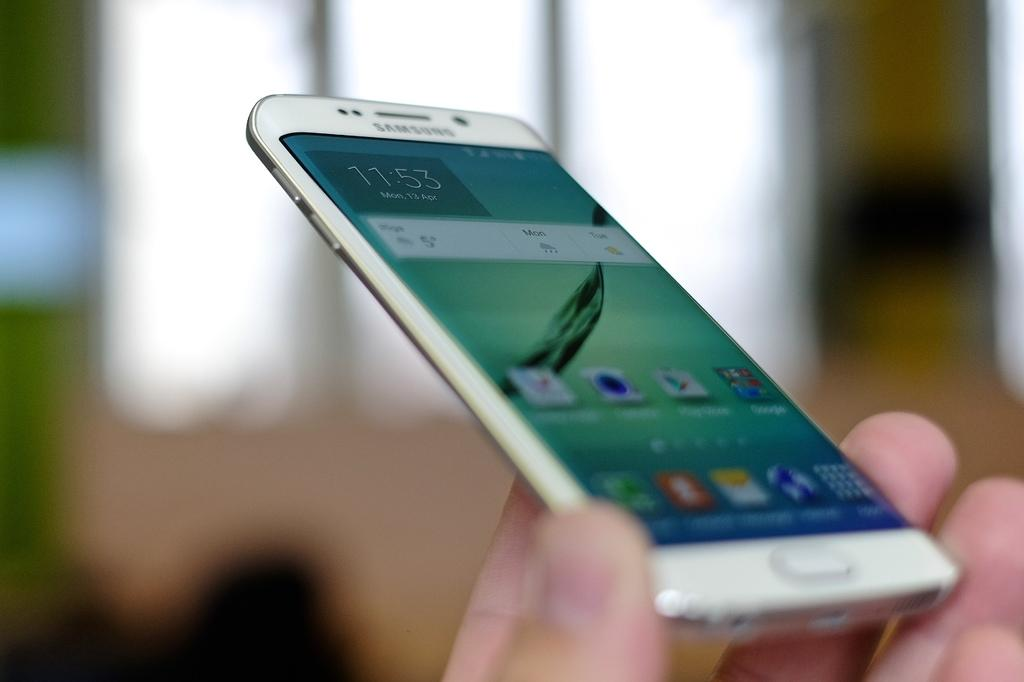What is being held by the hand in the image? There is a hand holding a mobile in the image. What can be seen on the mobile screen? The mobile screen displays applications. How many rings is the person wearing on their hand in the image? There is no information about rings or any jewelry on the hand in the image. 